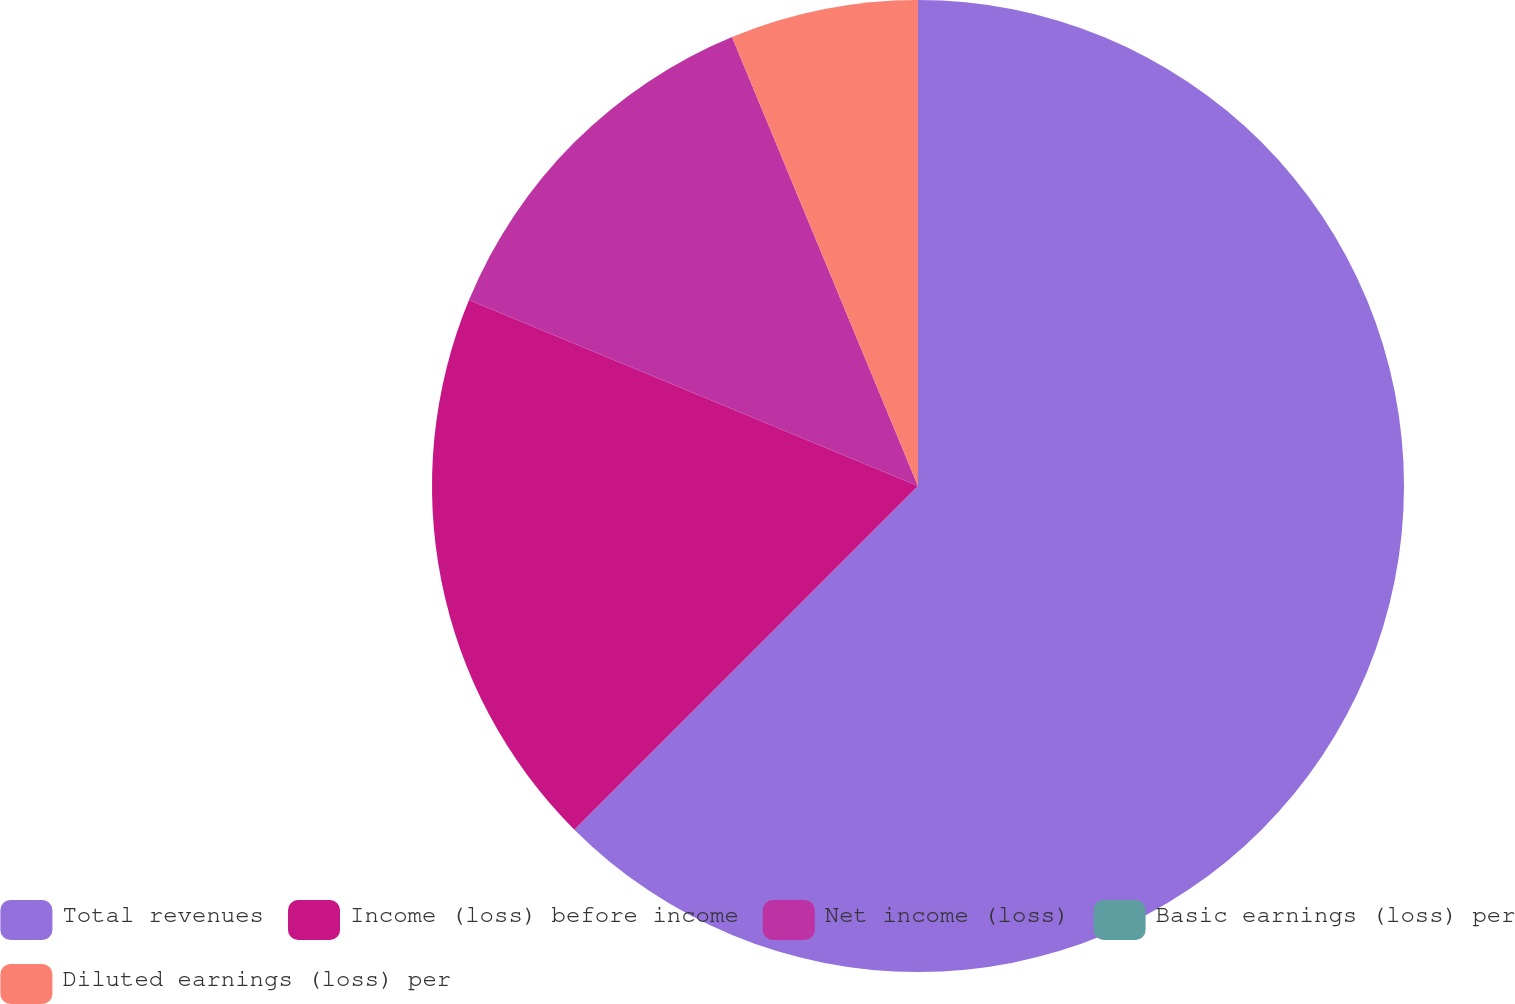Convert chart to OTSL. <chart><loc_0><loc_0><loc_500><loc_500><pie_chart><fcel>Total revenues<fcel>Income (loss) before income<fcel>Net income (loss)<fcel>Basic earnings (loss) per<fcel>Diluted earnings (loss) per<nl><fcel>62.5%<fcel>18.75%<fcel>12.5%<fcel>0.0%<fcel>6.25%<nl></chart> 